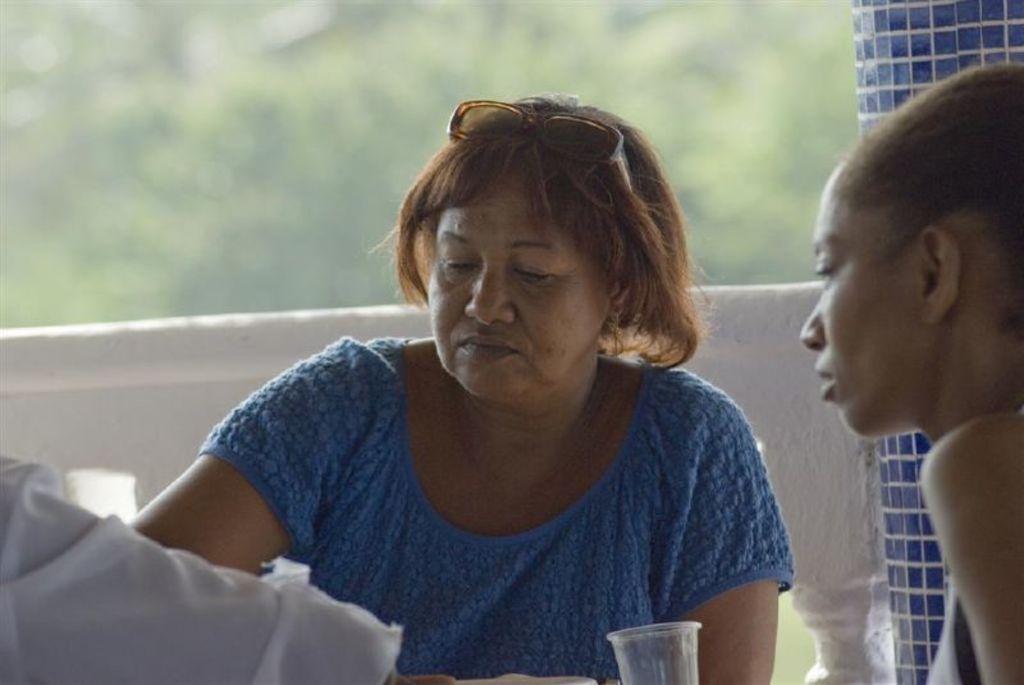How would you summarize this image in a sentence or two? In the image in the center, we can see two persons are sitting. In front of them, we can see one glass. In the background there is a pole and fence. 